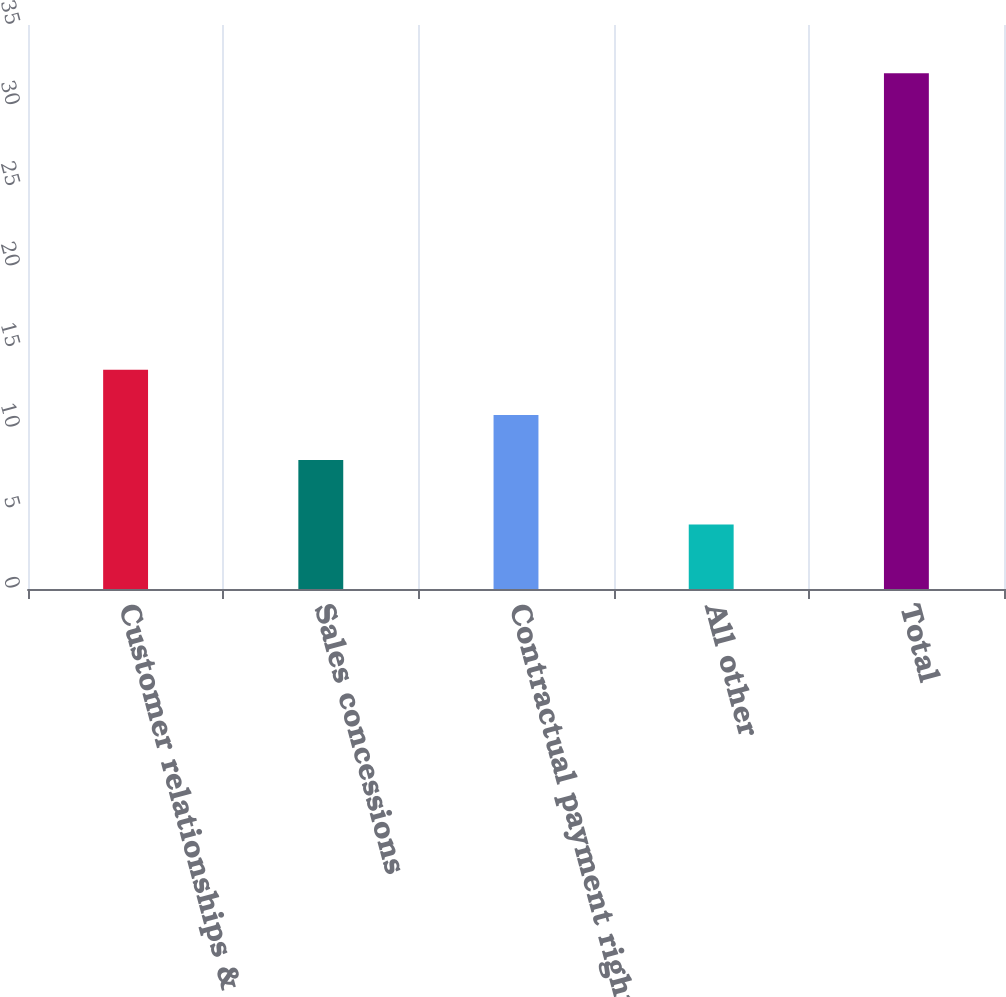Convert chart to OTSL. <chart><loc_0><loc_0><loc_500><loc_500><bar_chart><fcel>Customer relationships &<fcel>Sales concessions<fcel>Contractual payment rights<fcel>All other<fcel>Total<nl><fcel>13.6<fcel>8<fcel>10.8<fcel>4<fcel>32<nl></chart> 